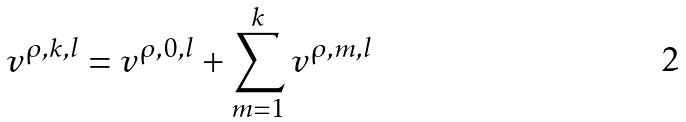Convert formula to latex. <formula><loc_0><loc_0><loc_500><loc_500>v ^ { \rho , k , l } = v ^ { \rho , 0 , l } + \sum _ { m = 1 } ^ { k } v ^ { \rho , m , l }</formula> 